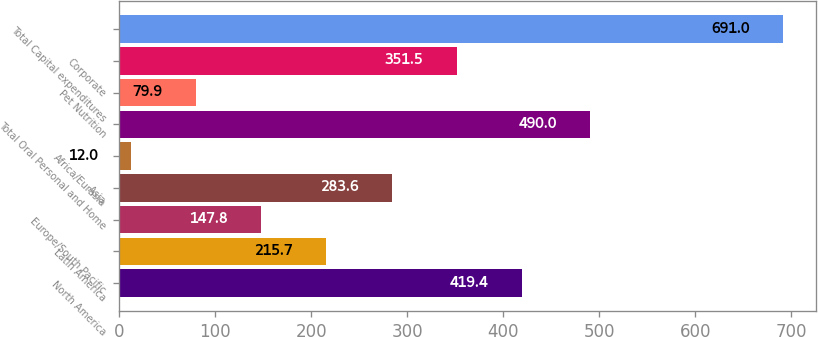Convert chart to OTSL. <chart><loc_0><loc_0><loc_500><loc_500><bar_chart><fcel>North America<fcel>Latin America<fcel>Europe/South Pacific<fcel>Asia<fcel>Africa/Eurasia<fcel>Total Oral Personal and Home<fcel>Pet Nutrition<fcel>Corporate<fcel>Total Capital expenditures<nl><fcel>419.4<fcel>215.7<fcel>147.8<fcel>283.6<fcel>12<fcel>490<fcel>79.9<fcel>351.5<fcel>691<nl></chart> 